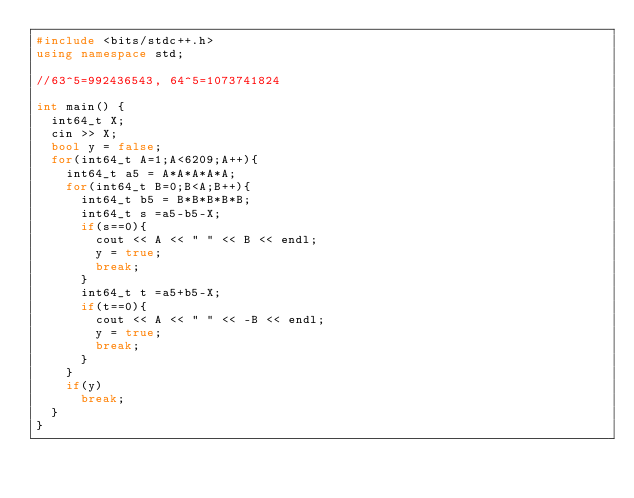Convert code to text. <code><loc_0><loc_0><loc_500><loc_500><_C++_>#include <bits/stdc++.h>
using namespace std;

//63^5=992436543, 64^5=1073741824

int main() {
  int64_t X;
  cin >> X;
  bool y = false;
  for(int64_t A=1;A<6209;A++){
    int64_t a5 = A*A*A*A*A;
    for(int64_t B=0;B<A;B++){
      int64_t b5 = B*B*B*B*B;
      int64_t s =a5-b5-X;
      if(s==0){
        cout << A << " " << B << endl;
        y = true;
        break;
      }
      int64_t t =a5+b5-X;
      if(t==0){
        cout << A << " " << -B << endl;
        y = true;
        break;
      }
    }
    if(y)
      break;
  }
}</code> 